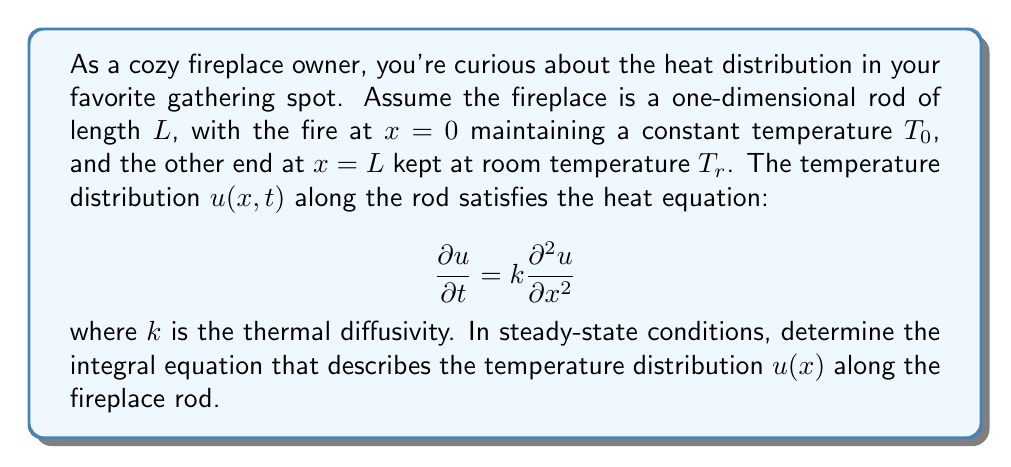Show me your answer to this math problem. Let's approach this step-by-step:

1) In steady-state conditions, the temperature doesn't change with time, so $\frac{\partial u}{\partial t} = 0$. The heat equation reduces to:

   $$k\frac{d^2u}{dx^2} = 0$$

2) Integrate this equation twice with respect to x:

   $$k\frac{du}{dx} = C_1$$
   $$ku = C_1x + C_2$$

3) Divide by k to get the general solution:

   $$u(x) = Ax + B$$

   where $A = \frac{C_1}{k}$ and $B = \frac{C_2}{k}$

4) Apply the boundary conditions:
   At x = 0, u(0) = T₀, so B = T₀
   At x = L, u(L) = Tᵣ, so AL + T₀ = Tᵣ

5) Solve for A:

   $$A = \frac{T_r - T_0}{L}$$

6) The temperature distribution is thus:

   $$u(x) = \frac{T_r - T_0}{L}x + T_0$$

7) To convert this into an integral equation, we can write:

   $$u(x) = T_0 + \int_0^x \frac{T_r - T_0}{L} dx'$$

This is the integral equation for the steady-state temperature distribution in the fireplace rod.
Answer: $$u(x) = T_0 + \int_0^x \frac{T_r - T_0}{L} dx'$$ 